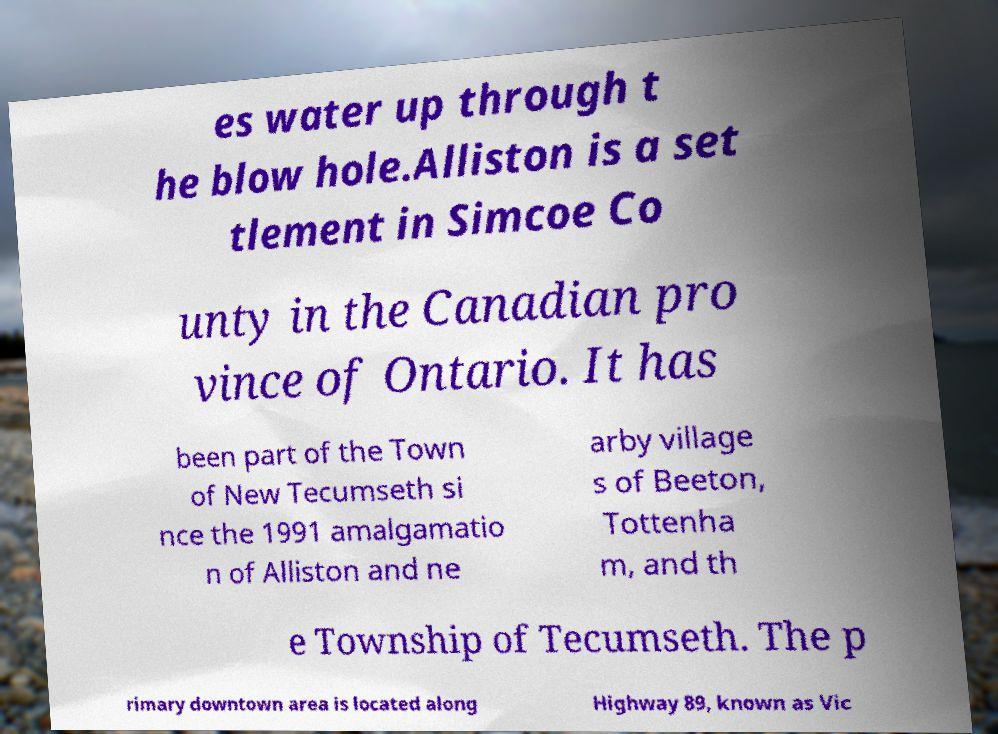What messages or text are displayed in this image? I need them in a readable, typed format. es water up through t he blow hole.Alliston is a set tlement in Simcoe Co unty in the Canadian pro vince of Ontario. It has been part of the Town of New Tecumseth si nce the 1991 amalgamatio n of Alliston and ne arby village s of Beeton, Tottenha m, and th e Township of Tecumseth. The p rimary downtown area is located along Highway 89, known as Vic 